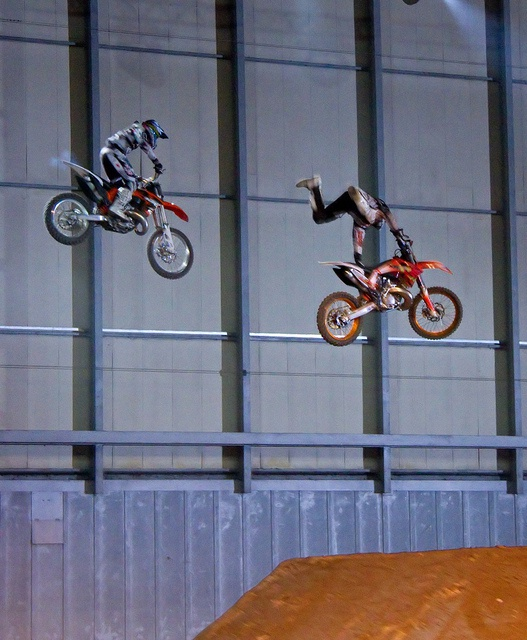Describe the objects in this image and their specific colors. I can see motorcycle in gray, black, and darkgray tones, motorcycle in gray, black, darkgray, and maroon tones, people in gray, black, and darkgray tones, and people in gray, black, and darkgray tones in this image. 